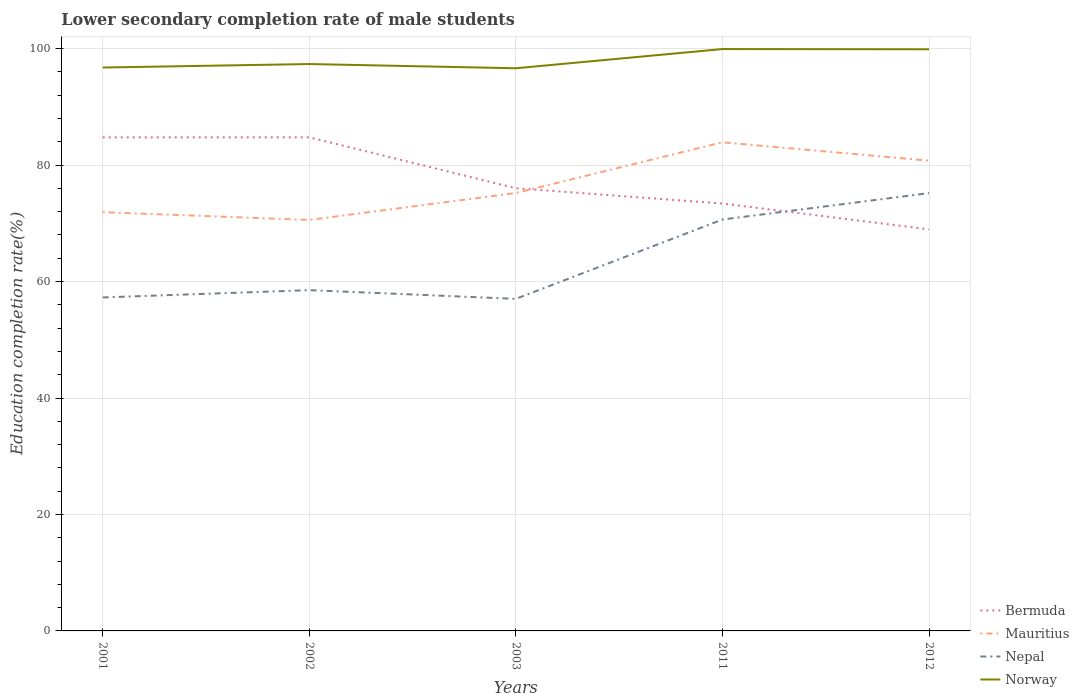Across all years, what is the maximum lower secondary completion rate of male students in Mauritius?
Offer a very short reply. 70.58. In which year was the lower secondary completion rate of male students in Bermuda maximum?
Your response must be concise. 2012. What is the total lower secondary completion rate of male students in Bermuda in the graph?
Your answer should be compact. -0.02. What is the difference between the highest and the second highest lower secondary completion rate of male students in Mauritius?
Offer a very short reply. 13.33. What is the difference between the highest and the lowest lower secondary completion rate of male students in Bermuda?
Ensure brevity in your answer.  2. How many lines are there?
Your response must be concise. 4. What is the difference between two consecutive major ticks on the Y-axis?
Your response must be concise. 20. Are the values on the major ticks of Y-axis written in scientific E-notation?
Provide a succinct answer. No. Does the graph contain grids?
Give a very brief answer. Yes. Where does the legend appear in the graph?
Provide a succinct answer. Bottom right. How are the legend labels stacked?
Offer a very short reply. Vertical. What is the title of the graph?
Offer a terse response. Lower secondary completion rate of male students. What is the label or title of the Y-axis?
Ensure brevity in your answer.  Education completion rate(%). What is the Education completion rate(%) in Bermuda in 2001?
Your response must be concise. 84.76. What is the Education completion rate(%) of Mauritius in 2001?
Your response must be concise. 71.91. What is the Education completion rate(%) of Nepal in 2001?
Your response must be concise. 57.27. What is the Education completion rate(%) in Norway in 2001?
Give a very brief answer. 96.76. What is the Education completion rate(%) of Bermuda in 2002?
Offer a very short reply. 84.77. What is the Education completion rate(%) of Mauritius in 2002?
Your answer should be very brief. 70.58. What is the Education completion rate(%) in Nepal in 2002?
Your answer should be compact. 58.52. What is the Education completion rate(%) of Norway in 2002?
Offer a very short reply. 97.36. What is the Education completion rate(%) in Bermuda in 2003?
Ensure brevity in your answer.  76.03. What is the Education completion rate(%) of Mauritius in 2003?
Provide a succinct answer. 75.21. What is the Education completion rate(%) of Nepal in 2003?
Your response must be concise. 57.03. What is the Education completion rate(%) of Norway in 2003?
Your answer should be very brief. 96.63. What is the Education completion rate(%) of Bermuda in 2011?
Ensure brevity in your answer.  73.4. What is the Education completion rate(%) of Mauritius in 2011?
Offer a very short reply. 83.91. What is the Education completion rate(%) in Nepal in 2011?
Provide a succinct answer. 70.65. What is the Education completion rate(%) of Norway in 2011?
Your answer should be very brief. 99.93. What is the Education completion rate(%) in Bermuda in 2012?
Offer a terse response. 68.97. What is the Education completion rate(%) of Mauritius in 2012?
Offer a terse response. 80.76. What is the Education completion rate(%) in Nepal in 2012?
Ensure brevity in your answer.  75.19. What is the Education completion rate(%) of Norway in 2012?
Give a very brief answer. 99.89. Across all years, what is the maximum Education completion rate(%) of Bermuda?
Your response must be concise. 84.77. Across all years, what is the maximum Education completion rate(%) of Mauritius?
Give a very brief answer. 83.91. Across all years, what is the maximum Education completion rate(%) in Nepal?
Provide a succinct answer. 75.19. Across all years, what is the maximum Education completion rate(%) of Norway?
Offer a terse response. 99.93. Across all years, what is the minimum Education completion rate(%) in Bermuda?
Ensure brevity in your answer.  68.97. Across all years, what is the minimum Education completion rate(%) in Mauritius?
Offer a very short reply. 70.58. Across all years, what is the minimum Education completion rate(%) in Nepal?
Give a very brief answer. 57.03. Across all years, what is the minimum Education completion rate(%) of Norway?
Offer a very short reply. 96.63. What is the total Education completion rate(%) in Bermuda in the graph?
Provide a short and direct response. 387.92. What is the total Education completion rate(%) in Mauritius in the graph?
Make the answer very short. 382.38. What is the total Education completion rate(%) in Nepal in the graph?
Keep it short and to the point. 318.66. What is the total Education completion rate(%) in Norway in the graph?
Your response must be concise. 490.56. What is the difference between the Education completion rate(%) in Bermuda in 2001 and that in 2002?
Provide a succinct answer. -0.02. What is the difference between the Education completion rate(%) in Mauritius in 2001 and that in 2002?
Your answer should be very brief. 1.33. What is the difference between the Education completion rate(%) of Nepal in 2001 and that in 2002?
Your answer should be very brief. -1.25. What is the difference between the Education completion rate(%) in Norway in 2001 and that in 2002?
Provide a short and direct response. -0.6. What is the difference between the Education completion rate(%) in Bermuda in 2001 and that in 2003?
Offer a terse response. 8.73. What is the difference between the Education completion rate(%) in Mauritius in 2001 and that in 2003?
Ensure brevity in your answer.  -3.29. What is the difference between the Education completion rate(%) in Nepal in 2001 and that in 2003?
Your answer should be compact. 0.24. What is the difference between the Education completion rate(%) of Norway in 2001 and that in 2003?
Ensure brevity in your answer.  0.13. What is the difference between the Education completion rate(%) in Bermuda in 2001 and that in 2011?
Keep it short and to the point. 11.36. What is the difference between the Education completion rate(%) of Mauritius in 2001 and that in 2011?
Provide a succinct answer. -12. What is the difference between the Education completion rate(%) of Nepal in 2001 and that in 2011?
Keep it short and to the point. -13.38. What is the difference between the Education completion rate(%) of Norway in 2001 and that in 2011?
Your answer should be very brief. -3.17. What is the difference between the Education completion rate(%) of Bermuda in 2001 and that in 2012?
Provide a short and direct response. 15.79. What is the difference between the Education completion rate(%) in Mauritius in 2001 and that in 2012?
Give a very brief answer. -8.85. What is the difference between the Education completion rate(%) of Nepal in 2001 and that in 2012?
Provide a short and direct response. -17.92. What is the difference between the Education completion rate(%) of Norway in 2001 and that in 2012?
Provide a succinct answer. -3.14. What is the difference between the Education completion rate(%) of Bermuda in 2002 and that in 2003?
Provide a short and direct response. 8.75. What is the difference between the Education completion rate(%) in Mauritius in 2002 and that in 2003?
Offer a very short reply. -4.62. What is the difference between the Education completion rate(%) of Nepal in 2002 and that in 2003?
Your answer should be compact. 1.5. What is the difference between the Education completion rate(%) of Norway in 2002 and that in 2003?
Ensure brevity in your answer.  0.73. What is the difference between the Education completion rate(%) of Bermuda in 2002 and that in 2011?
Your answer should be very brief. 11.37. What is the difference between the Education completion rate(%) in Mauritius in 2002 and that in 2011?
Provide a short and direct response. -13.33. What is the difference between the Education completion rate(%) in Nepal in 2002 and that in 2011?
Offer a terse response. -12.13. What is the difference between the Education completion rate(%) in Norway in 2002 and that in 2011?
Offer a very short reply. -2.57. What is the difference between the Education completion rate(%) of Bermuda in 2002 and that in 2012?
Your answer should be compact. 15.81. What is the difference between the Education completion rate(%) of Mauritius in 2002 and that in 2012?
Make the answer very short. -10.18. What is the difference between the Education completion rate(%) in Nepal in 2002 and that in 2012?
Your answer should be compact. -16.67. What is the difference between the Education completion rate(%) in Norway in 2002 and that in 2012?
Your answer should be compact. -2.54. What is the difference between the Education completion rate(%) in Bermuda in 2003 and that in 2011?
Your answer should be very brief. 2.63. What is the difference between the Education completion rate(%) of Mauritius in 2003 and that in 2011?
Ensure brevity in your answer.  -8.71. What is the difference between the Education completion rate(%) of Nepal in 2003 and that in 2011?
Offer a terse response. -13.63. What is the difference between the Education completion rate(%) in Norway in 2003 and that in 2011?
Your response must be concise. -3.3. What is the difference between the Education completion rate(%) in Bermuda in 2003 and that in 2012?
Your answer should be very brief. 7.06. What is the difference between the Education completion rate(%) of Mauritius in 2003 and that in 2012?
Provide a short and direct response. -5.56. What is the difference between the Education completion rate(%) in Nepal in 2003 and that in 2012?
Offer a terse response. -18.16. What is the difference between the Education completion rate(%) of Norway in 2003 and that in 2012?
Make the answer very short. -3.26. What is the difference between the Education completion rate(%) of Bermuda in 2011 and that in 2012?
Provide a succinct answer. 4.43. What is the difference between the Education completion rate(%) in Mauritius in 2011 and that in 2012?
Your answer should be very brief. 3.15. What is the difference between the Education completion rate(%) in Nepal in 2011 and that in 2012?
Ensure brevity in your answer.  -4.54. What is the difference between the Education completion rate(%) of Norway in 2011 and that in 2012?
Give a very brief answer. 0.04. What is the difference between the Education completion rate(%) in Bermuda in 2001 and the Education completion rate(%) in Mauritius in 2002?
Ensure brevity in your answer.  14.18. What is the difference between the Education completion rate(%) of Bermuda in 2001 and the Education completion rate(%) of Nepal in 2002?
Keep it short and to the point. 26.23. What is the difference between the Education completion rate(%) in Bermuda in 2001 and the Education completion rate(%) in Norway in 2002?
Your answer should be compact. -12.6. What is the difference between the Education completion rate(%) in Mauritius in 2001 and the Education completion rate(%) in Nepal in 2002?
Offer a terse response. 13.39. What is the difference between the Education completion rate(%) in Mauritius in 2001 and the Education completion rate(%) in Norway in 2002?
Your answer should be very brief. -25.45. What is the difference between the Education completion rate(%) in Nepal in 2001 and the Education completion rate(%) in Norway in 2002?
Your answer should be very brief. -40.09. What is the difference between the Education completion rate(%) in Bermuda in 2001 and the Education completion rate(%) in Mauritius in 2003?
Your response must be concise. 9.55. What is the difference between the Education completion rate(%) of Bermuda in 2001 and the Education completion rate(%) of Nepal in 2003?
Make the answer very short. 27.73. What is the difference between the Education completion rate(%) of Bermuda in 2001 and the Education completion rate(%) of Norway in 2003?
Provide a short and direct response. -11.87. What is the difference between the Education completion rate(%) of Mauritius in 2001 and the Education completion rate(%) of Nepal in 2003?
Offer a very short reply. 14.88. What is the difference between the Education completion rate(%) in Mauritius in 2001 and the Education completion rate(%) in Norway in 2003?
Make the answer very short. -24.72. What is the difference between the Education completion rate(%) of Nepal in 2001 and the Education completion rate(%) of Norway in 2003?
Offer a terse response. -39.36. What is the difference between the Education completion rate(%) of Bermuda in 2001 and the Education completion rate(%) of Mauritius in 2011?
Your answer should be compact. 0.84. What is the difference between the Education completion rate(%) of Bermuda in 2001 and the Education completion rate(%) of Nepal in 2011?
Your response must be concise. 14.1. What is the difference between the Education completion rate(%) of Bermuda in 2001 and the Education completion rate(%) of Norway in 2011?
Provide a short and direct response. -15.17. What is the difference between the Education completion rate(%) of Mauritius in 2001 and the Education completion rate(%) of Nepal in 2011?
Offer a very short reply. 1.26. What is the difference between the Education completion rate(%) in Mauritius in 2001 and the Education completion rate(%) in Norway in 2011?
Give a very brief answer. -28.02. What is the difference between the Education completion rate(%) of Nepal in 2001 and the Education completion rate(%) of Norway in 2011?
Keep it short and to the point. -42.66. What is the difference between the Education completion rate(%) of Bermuda in 2001 and the Education completion rate(%) of Mauritius in 2012?
Provide a short and direct response. 3.99. What is the difference between the Education completion rate(%) in Bermuda in 2001 and the Education completion rate(%) in Nepal in 2012?
Your answer should be very brief. 9.57. What is the difference between the Education completion rate(%) in Bermuda in 2001 and the Education completion rate(%) in Norway in 2012?
Offer a terse response. -15.13. What is the difference between the Education completion rate(%) of Mauritius in 2001 and the Education completion rate(%) of Nepal in 2012?
Your answer should be very brief. -3.28. What is the difference between the Education completion rate(%) in Mauritius in 2001 and the Education completion rate(%) in Norway in 2012?
Your answer should be compact. -27.98. What is the difference between the Education completion rate(%) of Nepal in 2001 and the Education completion rate(%) of Norway in 2012?
Ensure brevity in your answer.  -42.62. What is the difference between the Education completion rate(%) in Bermuda in 2002 and the Education completion rate(%) in Mauritius in 2003?
Your answer should be compact. 9.57. What is the difference between the Education completion rate(%) of Bermuda in 2002 and the Education completion rate(%) of Nepal in 2003?
Make the answer very short. 27.75. What is the difference between the Education completion rate(%) in Bermuda in 2002 and the Education completion rate(%) in Norway in 2003?
Your answer should be very brief. -11.86. What is the difference between the Education completion rate(%) of Mauritius in 2002 and the Education completion rate(%) of Nepal in 2003?
Your answer should be compact. 13.55. What is the difference between the Education completion rate(%) in Mauritius in 2002 and the Education completion rate(%) in Norway in 2003?
Provide a short and direct response. -26.05. What is the difference between the Education completion rate(%) of Nepal in 2002 and the Education completion rate(%) of Norway in 2003?
Give a very brief answer. -38.11. What is the difference between the Education completion rate(%) in Bermuda in 2002 and the Education completion rate(%) in Mauritius in 2011?
Make the answer very short. 0.86. What is the difference between the Education completion rate(%) of Bermuda in 2002 and the Education completion rate(%) of Nepal in 2011?
Your answer should be very brief. 14.12. What is the difference between the Education completion rate(%) in Bermuda in 2002 and the Education completion rate(%) in Norway in 2011?
Provide a succinct answer. -15.16. What is the difference between the Education completion rate(%) of Mauritius in 2002 and the Education completion rate(%) of Nepal in 2011?
Keep it short and to the point. -0.07. What is the difference between the Education completion rate(%) of Mauritius in 2002 and the Education completion rate(%) of Norway in 2011?
Keep it short and to the point. -29.35. What is the difference between the Education completion rate(%) in Nepal in 2002 and the Education completion rate(%) in Norway in 2011?
Provide a succinct answer. -41.4. What is the difference between the Education completion rate(%) in Bermuda in 2002 and the Education completion rate(%) in Mauritius in 2012?
Give a very brief answer. 4.01. What is the difference between the Education completion rate(%) of Bermuda in 2002 and the Education completion rate(%) of Nepal in 2012?
Your answer should be compact. 9.58. What is the difference between the Education completion rate(%) in Bermuda in 2002 and the Education completion rate(%) in Norway in 2012?
Offer a terse response. -15.12. What is the difference between the Education completion rate(%) in Mauritius in 2002 and the Education completion rate(%) in Nepal in 2012?
Your response must be concise. -4.61. What is the difference between the Education completion rate(%) of Mauritius in 2002 and the Education completion rate(%) of Norway in 2012?
Keep it short and to the point. -29.31. What is the difference between the Education completion rate(%) of Nepal in 2002 and the Education completion rate(%) of Norway in 2012?
Keep it short and to the point. -41.37. What is the difference between the Education completion rate(%) in Bermuda in 2003 and the Education completion rate(%) in Mauritius in 2011?
Make the answer very short. -7.89. What is the difference between the Education completion rate(%) of Bermuda in 2003 and the Education completion rate(%) of Nepal in 2011?
Your response must be concise. 5.37. What is the difference between the Education completion rate(%) in Bermuda in 2003 and the Education completion rate(%) in Norway in 2011?
Offer a very short reply. -23.9. What is the difference between the Education completion rate(%) of Mauritius in 2003 and the Education completion rate(%) of Nepal in 2011?
Make the answer very short. 4.55. What is the difference between the Education completion rate(%) in Mauritius in 2003 and the Education completion rate(%) in Norway in 2011?
Keep it short and to the point. -24.72. What is the difference between the Education completion rate(%) of Nepal in 2003 and the Education completion rate(%) of Norway in 2011?
Your answer should be compact. -42.9. What is the difference between the Education completion rate(%) in Bermuda in 2003 and the Education completion rate(%) in Mauritius in 2012?
Keep it short and to the point. -4.74. What is the difference between the Education completion rate(%) in Bermuda in 2003 and the Education completion rate(%) in Nepal in 2012?
Provide a succinct answer. 0.84. What is the difference between the Education completion rate(%) of Bermuda in 2003 and the Education completion rate(%) of Norway in 2012?
Provide a short and direct response. -23.86. What is the difference between the Education completion rate(%) of Mauritius in 2003 and the Education completion rate(%) of Nepal in 2012?
Give a very brief answer. 0.02. What is the difference between the Education completion rate(%) in Mauritius in 2003 and the Education completion rate(%) in Norway in 2012?
Your answer should be very brief. -24.69. What is the difference between the Education completion rate(%) in Nepal in 2003 and the Education completion rate(%) in Norway in 2012?
Give a very brief answer. -42.86. What is the difference between the Education completion rate(%) of Bermuda in 2011 and the Education completion rate(%) of Mauritius in 2012?
Your response must be concise. -7.37. What is the difference between the Education completion rate(%) in Bermuda in 2011 and the Education completion rate(%) in Nepal in 2012?
Your response must be concise. -1.79. What is the difference between the Education completion rate(%) in Bermuda in 2011 and the Education completion rate(%) in Norway in 2012?
Your answer should be very brief. -26.49. What is the difference between the Education completion rate(%) of Mauritius in 2011 and the Education completion rate(%) of Nepal in 2012?
Provide a succinct answer. 8.73. What is the difference between the Education completion rate(%) of Mauritius in 2011 and the Education completion rate(%) of Norway in 2012?
Ensure brevity in your answer.  -15.98. What is the difference between the Education completion rate(%) of Nepal in 2011 and the Education completion rate(%) of Norway in 2012?
Your answer should be very brief. -29.24. What is the average Education completion rate(%) in Bermuda per year?
Keep it short and to the point. 77.58. What is the average Education completion rate(%) in Mauritius per year?
Make the answer very short. 76.48. What is the average Education completion rate(%) of Nepal per year?
Offer a very short reply. 63.73. What is the average Education completion rate(%) of Norway per year?
Your answer should be compact. 98.11. In the year 2001, what is the difference between the Education completion rate(%) of Bermuda and Education completion rate(%) of Mauritius?
Give a very brief answer. 12.85. In the year 2001, what is the difference between the Education completion rate(%) of Bermuda and Education completion rate(%) of Nepal?
Make the answer very short. 27.49. In the year 2001, what is the difference between the Education completion rate(%) in Bermuda and Education completion rate(%) in Norway?
Your answer should be very brief. -12. In the year 2001, what is the difference between the Education completion rate(%) in Mauritius and Education completion rate(%) in Nepal?
Ensure brevity in your answer.  14.64. In the year 2001, what is the difference between the Education completion rate(%) in Mauritius and Education completion rate(%) in Norway?
Offer a terse response. -24.85. In the year 2001, what is the difference between the Education completion rate(%) of Nepal and Education completion rate(%) of Norway?
Your answer should be very brief. -39.49. In the year 2002, what is the difference between the Education completion rate(%) of Bermuda and Education completion rate(%) of Mauritius?
Provide a short and direct response. 14.19. In the year 2002, what is the difference between the Education completion rate(%) of Bermuda and Education completion rate(%) of Nepal?
Your answer should be compact. 26.25. In the year 2002, what is the difference between the Education completion rate(%) of Bermuda and Education completion rate(%) of Norway?
Your answer should be very brief. -12.58. In the year 2002, what is the difference between the Education completion rate(%) of Mauritius and Education completion rate(%) of Nepal?
Give a very brief answer. 12.06. In the year 2002, what is the difference between the Education completion rate(%) of Mauritius and Education completion rate(%) of Norway?
Keep it short and to the point. -26.77. In the year 2002, what is the difference between the Education completion rate(%) in Nepal and Education completion rate(%) in Norway?
Keep it short and to the point. -38.83. In the year 2003, what is the difference between the Education completion rate(%) in Bermuda and Education completion rate(%) in Mauritius?
Your response must be concise. 0.82. In the year 2003, what is the difference between the Education completion rate(%) of Bermuda and Education completion rate(%) of Nepal?
Give a very brief answer. 19. In the year 2003, what is the difference between the Education completion rate(%) in Bermuda and Education completion rate(%) in Norway?
Your response must be concise. -20.6. In the year 2003, what is the difference between the Education completion rate(%) in Mauritius and Education completion rate(%) in Nepal?
Your answer should be very brief. 18.18. In the year 2003, what is the difference between the Education completion rate(%) in Mauritius and Education completion rate(%) in Norway?
Give a very brief answer. -21.43. In the year 2003, what is the difference between the Education completion rate(%) of Nepal and Education completion rate(%) of Norway?
Keep it short and to the point. -39.6. In the year 2011, what is the difference between the Education completion rate(%) of Bermuda and Education completion rate(%) of Mauritius?
Your answer should be very brief. -10.52. In the year 2011, what is the difference between the Education completion rate(%) in Bermuda and Education completion rate(%) in Nepal?
Offer a very short reply. 2.75. In the year 2011, what is the difference between the Education completion rate(%) in Bermuda and Education completion rate(%) in Norway?
Keep it short and to the point. -26.53. In the year 2011, what is the difference between the Education completion rate(%) of Mauritius and Education completion rate(%) of Nepal?
Keep it short and to the point. 13.26. In the year 2011, what is the difference between the Education completion rate(%) of Mauritius and Education completion rate(%) of Norway?
Your answer should be very brief. -16.01. In the year 2011, what is the difference between the Education completion rate(%) of Nepal and Education completion rate(%) of Norway?
Offer a terse response. -29.27. In the year 2012, what is the difference between the Education completion rate(%) in Bermuda and Education completion rate(%) in Mauritius?
Ensure brevity in your answer.  -11.8. In the year 2012, what is the difference between the Education completion rate(%) in Bermuda and Education completion rate(%) in Nepal?
Your response must be concise. -6.22. In the year 2012, what is the difference between the Education completion rate(%) of Bermuda and Education completion rate(%) of Norway?
Your response must be concise. -30.93. In the year 2012, what is the difference between the Education completion rate(%) in Mauritius and Education completion rate(%) in Nepal?
Keep it short and to the point. 5.58. In the year 2012, what is the difference between the Education completion rate(%) of Mauritius and Education completion rate(%) of Norway?
Keep it short and to the point. -19.13. In the year 2012, what is the difference between the Education completion rate(%) of Nepal and Education completion rate(%) of Norway?
Provide a succinct answer. -24.7. What is the ratio of the Education completion rate(%) in Bermuda in 2001 to that in 2002?
Keep it short and to the point. 1. What is the ratio of the Education completion rate(%) of Mauritius in 2001 to that in 2002?
Offer a terse response. 1.02. What is the ratio of the Education completion rate(%) of Nepal in 2001 to that in 2002?
Provide a short and direct response. 0.98. What is the ratio of the Education completion rate(%) of Norway in 2001 to that in 2002?
Keep it short and to the point. 0.99. What is the ratio of the Education completion rate(%) in Bermuda in 2001 to that in 2003?
Provide a succinct answer. 1.11. What is the ratio of the Education completion rate(%) in Mauritius in 2001 to that in 2003?
Offer a very short reply. 0.96. What is the ratio of the Education completion rate(%) of Norway in 2001 to that in 2003?
Your response must be concise. 1. What is the ratio of the Education completion rate(%) of Bermuda in 2001 to that in 2011?
Offer a terse response. 1.15. What is the ratio of the Education completion rate(%) in Mauritius in 2001 to that in 2011?
Offer a terse response. 0.86. What is the ratio of the Education completion rate(%) in Nepal in 2001 to that in 2011?
Give a very brief answer. 0.81. What is the ratio of the Education completion rate(%) in Norway in 2001 to that in 2011?
Give a very brief answer. 0.97. What is the ratio of the Education completion rate(%) of Bermuda in 2001 to that in 2012?
Your answer should be compact. 1.23. What is the ratio of the Education completion rate(%) in Mauritius in 2001 to that in 2012?
Give a very brief answer. 0.89. What is the ratio of the Education completion rate(%) in Nepal in 2001 to that in 2012?
Keep it short and to the point. 0.76. What is the ratio of the Education completion rate(%) of Norway in 2001 to that in 2012?
Keep it short and to the point. 0.97. What is the ratio of the Education completion rate(%) in Bermuda in 2002 to that in 2003?
Ensure brevity in your answer.  1.11. What is the ratio of the Education completion rate(%) of Mauritius in 2002 to that in 2003?
Offer a very short reply. 0.94. What is the ratio of the Education completion rate(%) of Nepal in 2002 to that in 2003?
Make the answer very short. 1.03. What is the ratio of the Education completion rate(%) of Norway in 2002 to that in 2003?
Offer a very short reply. 1.01. What is the ratio of the Education completion rate(%) of Bermuda in 2002 to that in 2011?
Your answer should be compact. 1.16. What is the ratio of the Education completion rate(%) of Mauritius in 2002 to that in 2011?
Give a very brief answer. 0.84. What is the ratio of the Education completion rate(%) of Nepal in 2002 to that in 2011?
Provide a short and direct response. 0.83. What is the ratio of the Education completion rate(%) in Norway in 2002 to that in 2011?
Keep it short and to the point. 0.97. What is the ratio of the Education completion rate(%) in Bermuda in 2002 to that in 2012?
Ensure brevity in your answer.  1.23. What is the ratio of the Education completion rate(%) in Mauritius in 2002 to that in 2012?
Your answer should be compact. 0.87. What is the ratio of the Education completion rate(%) in Nepal in 2002 to that in 2012?
Your answer should be compact. 0.78. What is the ratio of the Education completion rate(%) of Norway in 2002 to that in 2012?
Offer a terse response. 0.97. What is the ratio of the Education completion rate(%) in Bermuda in 2003 to that in 2011?
Provide a succinct answer. 1.04. What is the ratio of the Education completion rate(%) of Mauritius in 2003 to that in 2011?
Provide a succinct answer. 0.9. What is the ratio of the Education completion rate(%) in Nepal in 2003 to that in 2011?
Your answer should be compact. 0.81. What is the ratio of the Education completion rate(%) in Norway in 2003 to that in 2011?
Keep it short and to the point. 0.97. What is the ratio of the Education completion rate(%) of Bermuda in 2003 to that in 2012?
Your response must be concise. 1.1. What is the ratio of the Education completion rate(%) of Mauritius in 2003 to that in 2012?
Offer a very short reply. 0.93. What is the ratio of the Education completion rate(%) in Nepal in 2003 to that in 2012?
Provide a short and direct response. 0.76. What is the ratio of the Education completion rate(%) of Norway in 2003 to that in 2012?
Make the answer very short. 0.97. What is the ratio of the Education completion rate(%) of Bermuda in 2011 to that in 2012?
Offer a terse response. 1.06. What is the ratio of the Education completion rate(%) of Mauritius in 2011 to that in 2012?
Keep it short and to the point. 1.04. What is the ratio of the Education completion rate(%) in Nepal in 2011 to that in 2012?
Offer a very short reply. 0.94. What is the ratio of the Education completion rate(%) of Norway in 2011 to that in 2012?
Your answer should be compact. 1. What is the difference between the highest and the second highest Education completion rate(%) in Bermuda?
Give a very brief answer. 0.02. What is the difference between the highest and the second highest Education completion rate(%) of Mauritius?
Offer a terse response. 3.15. What is the difference between the highest and the second highest Education completion rate(%) of Nepal?
Ensure brevity in your answer.  4.54. What is the difference between the highest and the second highest Education completion rate(%) in Norway?
Your response must be concise. 0.04. What is the difference between the highest and the lowest Education completion rate(%) in Bermuda?
Provide a succinct answer. 15.81. What is the difference between the highest and the lowest Education completion rate(%) of Mauritius?
Provide a succinct answer. 13.33. What is the difference between the highest and the lowest Education completion rate(%) of Nepal?
Provide a succinct answer. 18.16. What is the difference between the highest and the lowest Education completion rate(%) of Norway?
Your response must be concise. 3.3. 